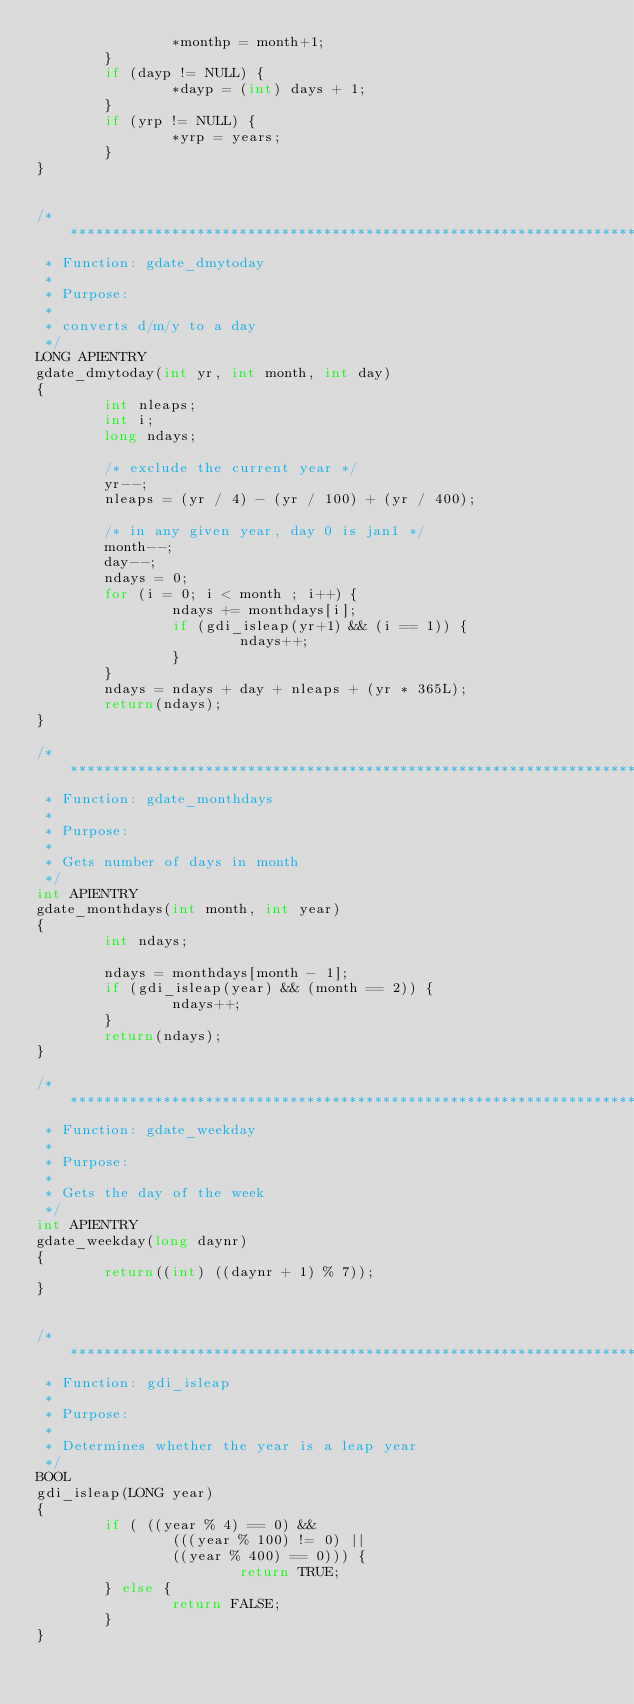Convert code to text. <code><loc_0><loc_0><loc_500><loc_500><_C_>                *monthp = month+1;
        }
        if (dayp != NULL) {
                *dayp = (int) days + 1;
        }
        if (yrp != NULL) {
                *yrp = years;
        }
}


/***************************************************************************
 * Function: gdate_dmytoday
 *
 * Purpose:
 *
 * converts d/m/y to a day
 */ 
LONG APIENTRY
gdate_dmytoday(int yr, int month, int day)
{
        int nleaps;
        int i;
        long ndays;

        /* exclude the current year */
        yr--;
        nleaps = (yr / 4) - (yr / 100) + (yr / 400);

        /* in any given year, day 0 is jan1 */
        month--;
        day--;
        ndays = 0;
        for (i = 0; i < month ; i++) {
                ndays += monthdays[i];
                if (gdi_isleap(yr+1) && (i == 1)) {
                        ndays++;
                }
        }
        ndays = ndays + day + nleaps + (yr * 365L);
        return(ndays);
}

/***************************************************************************
 * Function: gdate_monthdays
 *
 * Purpose:
 *
 * Gets number of days in month
 */
int APIENTRY
gdate_monthdays(int month, int year)
{
        int ndays;

        ndays = monthdays[month - 1];
        if (gdi_isleap(year) && (month == 2)) {
                ndays++;
        }
        return(ndays);
}

/***************************************************************************
 * Function: gdate_weekday
 *
 * Purpose:
 * 
 * Gets the day of the week
 */
int APIENTRY
gdate_weekday(long daynr)
{
        return((int) ((daynr + 1) % 7));
}


/***************************************************************************
 * Function: gdi_isleap
 *
 * Purpose:
 * 
 * Determines whether the year is a leap year
 */
BOOL
gdi_isleap(LONG year)
{
        if ( ((year % 4) == 0) &&
                (((year % 100) != 0) ||
                ((year % 400) == 0))) {
                        return TRUE;
        } else {
                return FALSE;
        }
}
</code> 